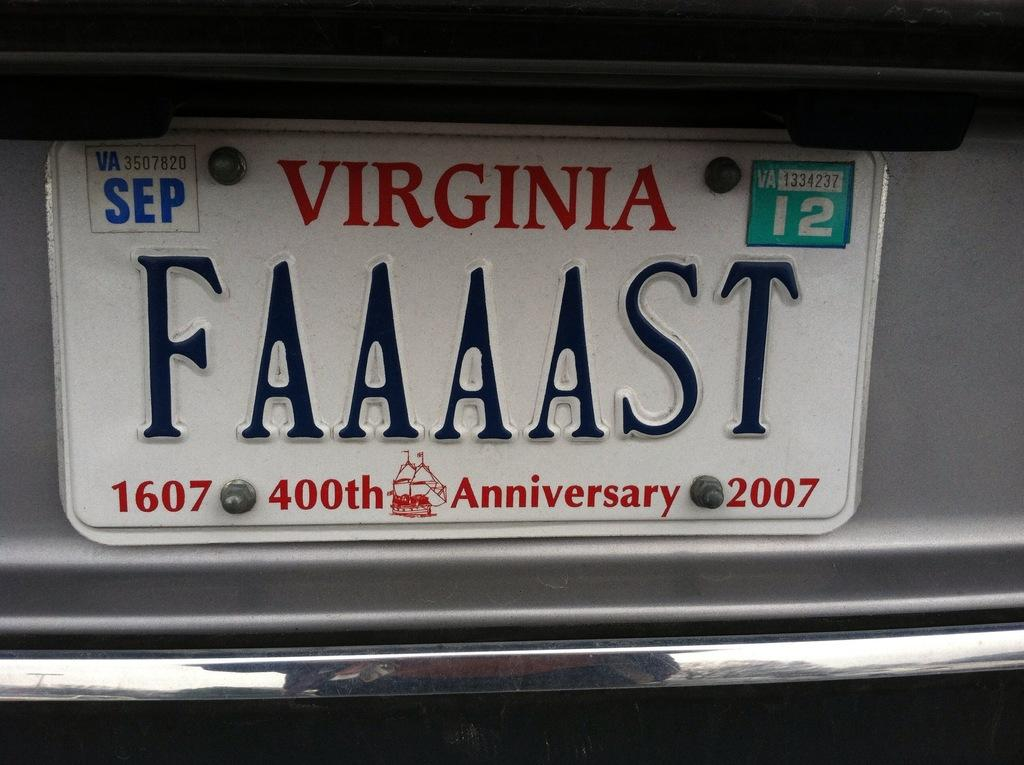What can be seen on the vehicle in the image? There is a number plate of a vehicle in the image. Can you describe the number plate? Unfortunately, the details of the number plate cannot be determined from the image alone. What might the number plate be used for? The number plate is likely used for identification purposes, such as tracking the vehicle or registering it with authorities. How many lizards are crawling on the number plate in the image? There are no lizards present in the image; it only features the number plate of a vehicle. What type of currency is depicted on the number plate in the image? There is no currency or cent symbol present on the number plate in the image. 